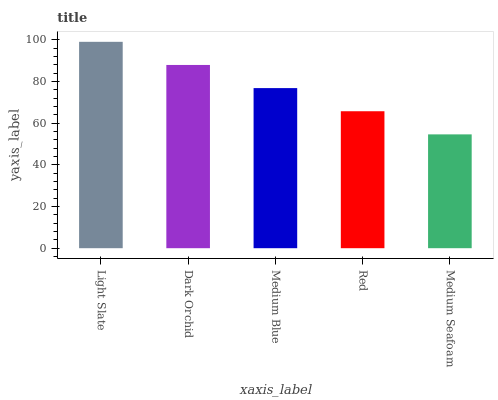Is Medium Seafoam the minimum?
Answer yes or no. Yes. Is Light Slate the maximum?
Answer yes or no. Yes. Is Dark Orchid the minimum?
Answer yes or no. No. Is Dark Orchid the maximum?
Answer yes or no. No. Is Light Slate greater than Dark Orchid?
Answer yes or no. Yes. Is Dark Orchid less than Light Slate?
Answer yes or no. Yes. Is Dark Orchid greater than Light Slate?
Answer yes or no. No. Is Light Slate less than Dark Orchid?
Answer yes or no. No. Is Medium Blue the high median?
Answer yes or no. Yes. Is Medium Blue the low median?
Answer yes or no. Yes. Is Red the high median?
Answer yes or no. No. Is Red the low median?
Answer yes or no. No. 